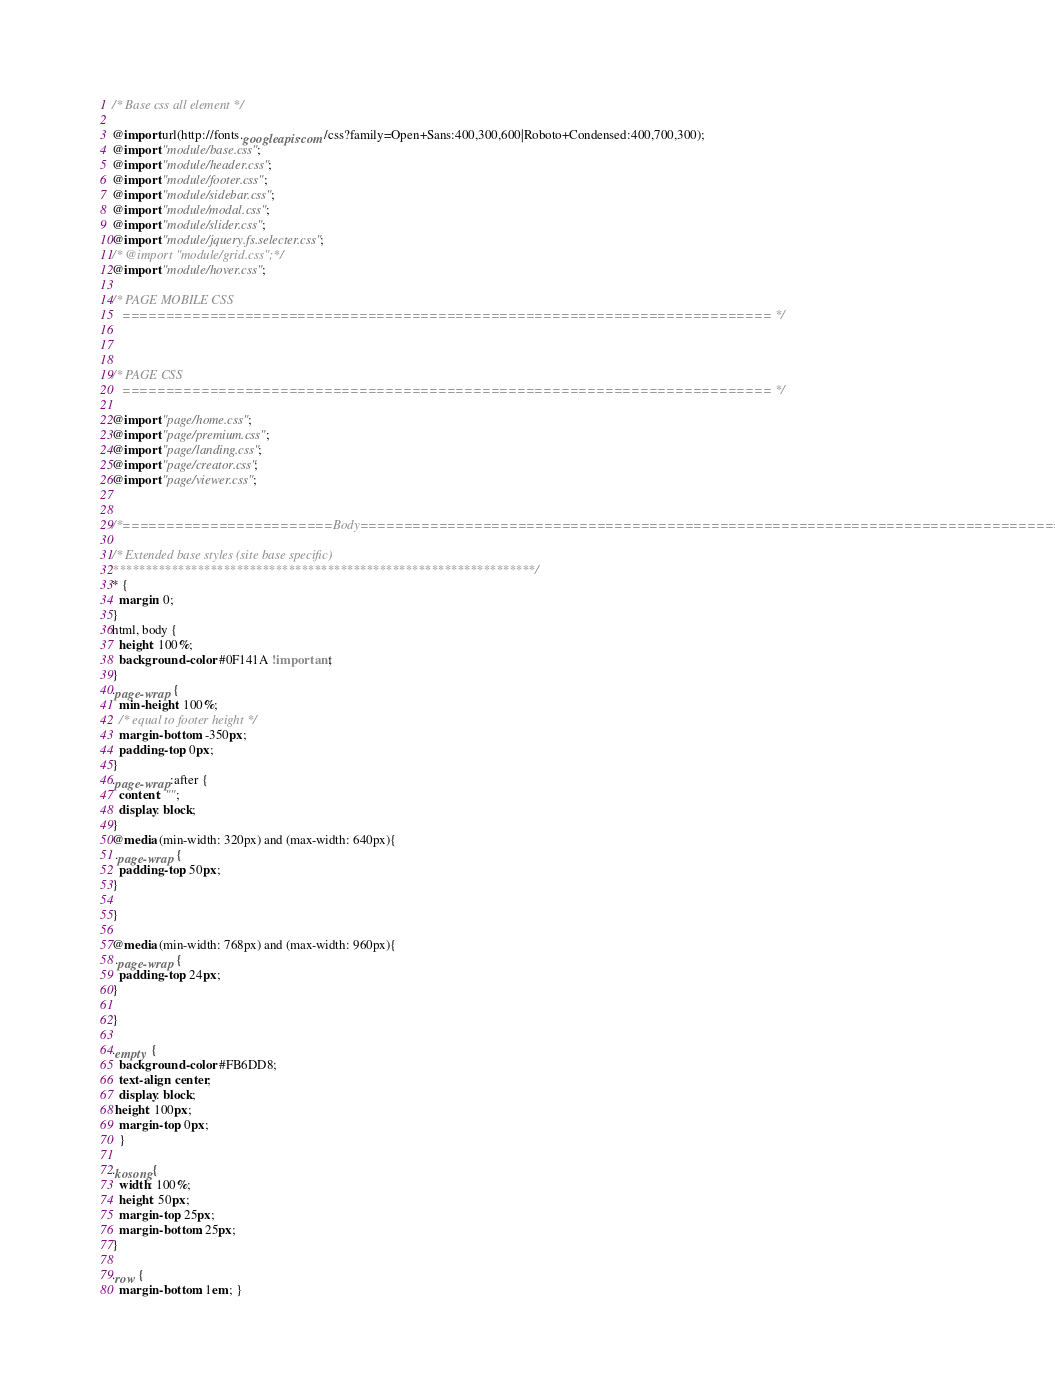Convert code to text. <code><loc_0><loc_0><loc_500><loc_500><_CSS_>/* Base css all element */

@import url(http://fonts.googleapis.com/css?family=Open+Sans:400,300,600|Roboto+Condensed:400,700,300);
@import "module/base.css";
@import "module/header.css";
@import "module/footer.css";
@import "module/sidebar.css";
@import "module/modal.css";
@import "module/slider.css";
@import "module/jquery.fs.selecter.css";
/* @import "module/grid.css";*/
@import "module/hover.css";

/* PAGE MOBILE CSS
   ========================================================================== */



/* PAGE CSS
   ========================================================================== */

@import "page/home.css";
@import "page/premium.css";
@import "page/landing.css";
@import "page/creator.css";
@import "page/viewer.css";


/*========================Body==================================================================================== */

/* Extended base styles (site base specific)
*****************************************************************/
* {
  margin: 0;
}
html, body {
  height: 100%;
  background-color: #0F141A !important;
}
.page-wrap {
  min-height: 100%;
  /* equal to footer height */
  margin-bottom: -350px; 
  padding-top: 0px;
}
.page-wrap:after {
  content: "";
  display: block;
}
@media (min-width: 320px) and (max-width: 640px){
 .page-wrap {
  padding-top: 50px;
}

}

@media (min-width: 768px) and (max-width: 960px){
 .page-wrap {
  padding-top: 24px;
}

}

.empty {
  background-color: #FB6DD8;
  text-align: center;
  display: block;
 height: 100px;
  margin-top: 0px;
  }

.kosong{
  width: 100%;
  height: 50px;
  margin-top: 25px;
  margin-bottom: 25px;
}

.row {
  margin-bottom: 1em; }

</code> 